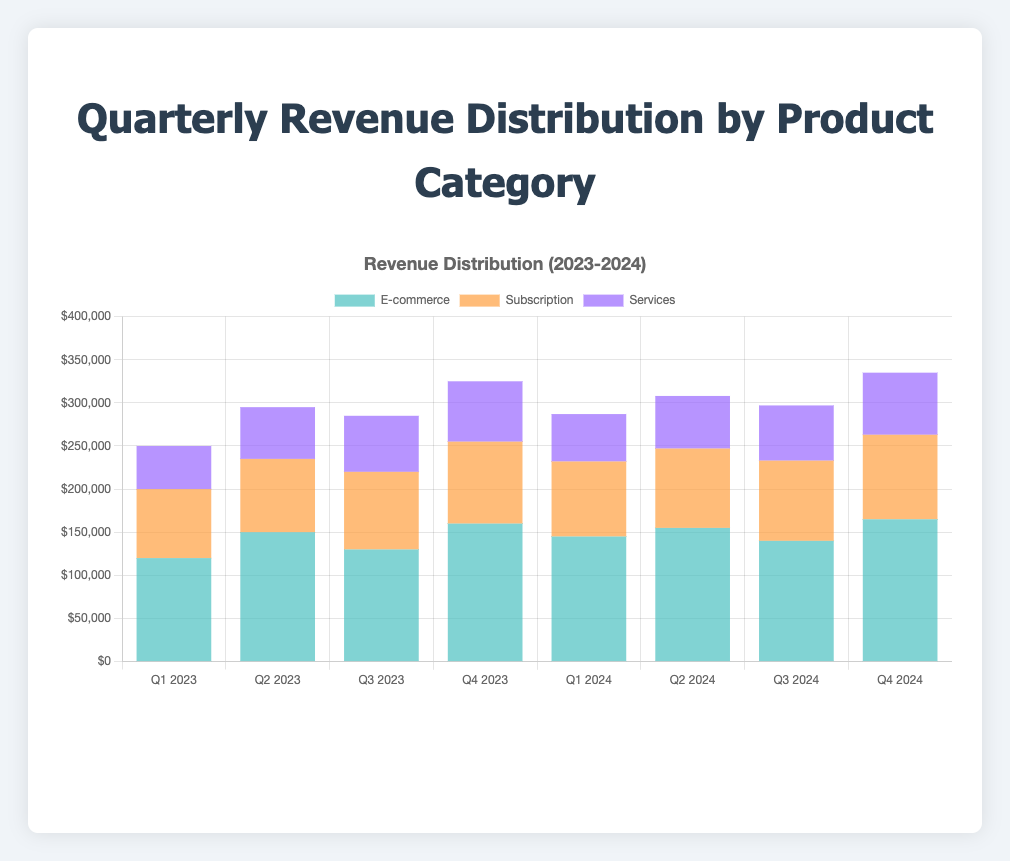What is the total revenue for Q1 2023? Sum the revenue from E-commerce, Subscription, and Services for Q1 2023: $120,000 + $80,000 + $50,000 = $250,000
Answer: $250,000 Which quarter had the highest revenue from E-commerce? Compare the E-commerce revenue across all quarters, and Q4 2024 has the highest value at $165,000
Answer: Q4 2024 What was the trend in Subscription revenue from Q1 2023 to Q4 2024? Observe the Subscription revenue for each quarter: $80,000 → $85,000 → $90,000 → $95,000 → $87,000 → $92,000 → $93,000 → $98,000. The trend shows a general increase with some slight fluctuations
Answer: General increase How much higher is the total revenue in Q4 2024 compared to Q1 2024? Calculate the total revenue for both quarters: Q4 2024: $165,000 + $98,000 + $72,000 = $335,000, Q1 2024: $145,000 + $87,000 + $55,000 = $287,000. The difference is $335,000 - $287,000 = $48,000
Answer: $48,000 During which quarter did Services see the maximum revenue? Compare Services revenue across all quarters and Q4 2024 has the highest value at $72,000
Answer: Q4 2024 What is the average E-commerce revenue over the observed quarters? Sum all the E-commerce revenues and divide by the number of quarters: ($120,000 + $150,000 + $130,000 + $160,000 + $145,000 + $155,000 + $140,000 + $165,000) / 8 = $146,875
Answer: $146,875 Which product category contributed least to the total revenue in Q2 2023? Add revenues for Q2 2023: E-commerce $150,000, Subscription $85,000, Services $60,000. The lowest contribution is from Services
Answer: Services By how much did Subscription revenue increase from Q1 2023 to Q4 2023? Subscription revenue in Q1 2023 was $80,000 and in Q4 2023 was $95,000. The increase is $95,000 - $80,000 = $15,000
Answer: $15,000 Which quarter showed a decline in E-commerce revenue compared to the previous quarter? Compare E-commerce revenue each quarter: Q1 2023 → Q2 2023 ($120,000 → $150,000), Q2 2023 → Q3 2023 ($150,000 → $130,000). So, Q3 2023 showed a decline compared to Q2 2023
Answer: Q3 2023 What was the combined revenue from Services in the first and last quarters? Sum the Services revenue for Q1 2023 and Q4 2024: $50,000 + $72,000 = $122,000
Answer: $122,000 